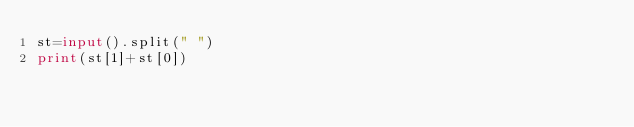<code> <loc_0><loc_0><loc_500><loc_500><_Python_>st=input().split(" ")
print(st[1]+st[0])</code> 